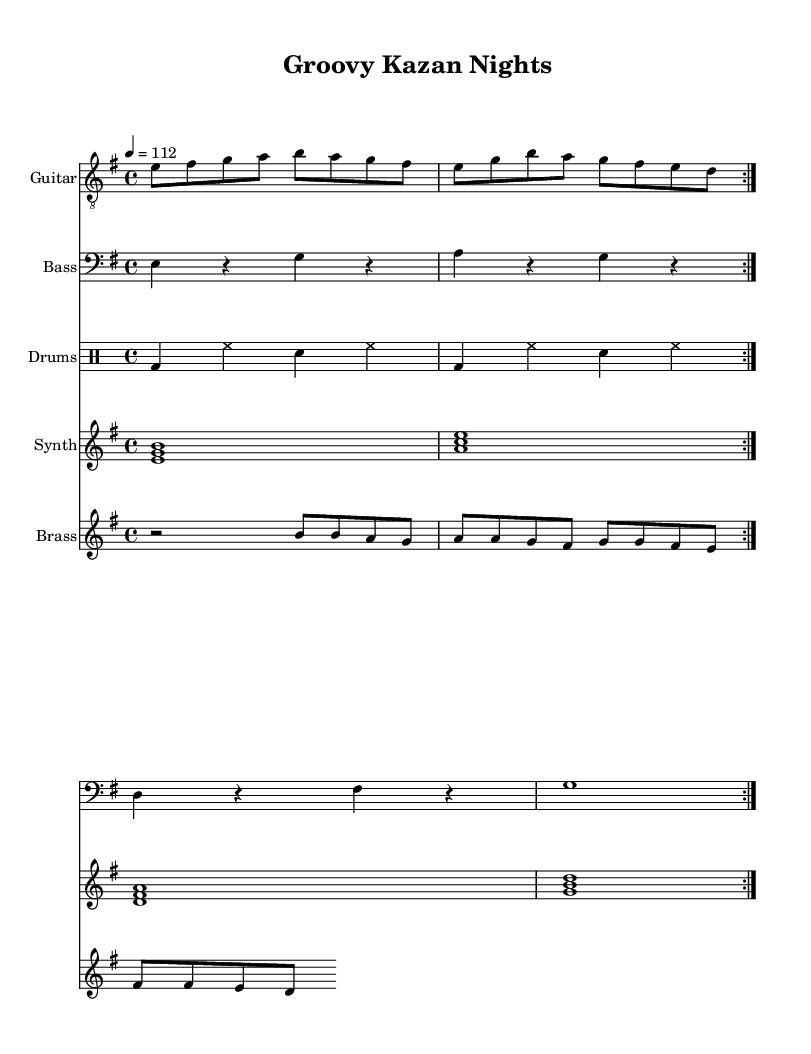What is the key signature of this music? The key signature is E minor, which has one sharp (F#). This can be identified by looking at the key signature indicated at the beginning of the staff, which shows one sharp.
Answer: E minor What is the time signature of the piece? The time signature is 4/4, which means there are four beats per measure, and each quarter note gets one beat. This is indicated at the beginning of the score.
Answer: 4/4 What is the tempo marking for the music? The tempo marking is 112 beats per minute, indicated as "4 = 112" at the top of the music. This specifies how fast the piece should be played.
Answer: 112 How many bars are repeated in the main guitar part? The main guitar part contains two repeated bars, as indicated by the "repeat volta 2" instruction at the beginning of the section. This shows that the specific musical section should be played two times.
Answer: 2 What type of instrument is used for the bass part? The bass part is played on a bass guitar, as labeled on the staff for that part of the score. The staff explicitly indicates "Bass" for the instrument used.
Answer: Bass guitar Which chord appears first in the synth part? The first chord in the synth part is E minor, indicated by the notes E, G, and B written simultaneously, demonstrating the voicing of the chord right at the beginning of the repeated section.
Answer: E minor What rhythmic pattern is used for the drums? The rhythmic pattern for the drums alternates between bass drum and snare, with hi-hat hits in between. This is shown in the drum notation where the bass and snare pattern is visually represented in the repeated sections.
Answer: Bass and snare 